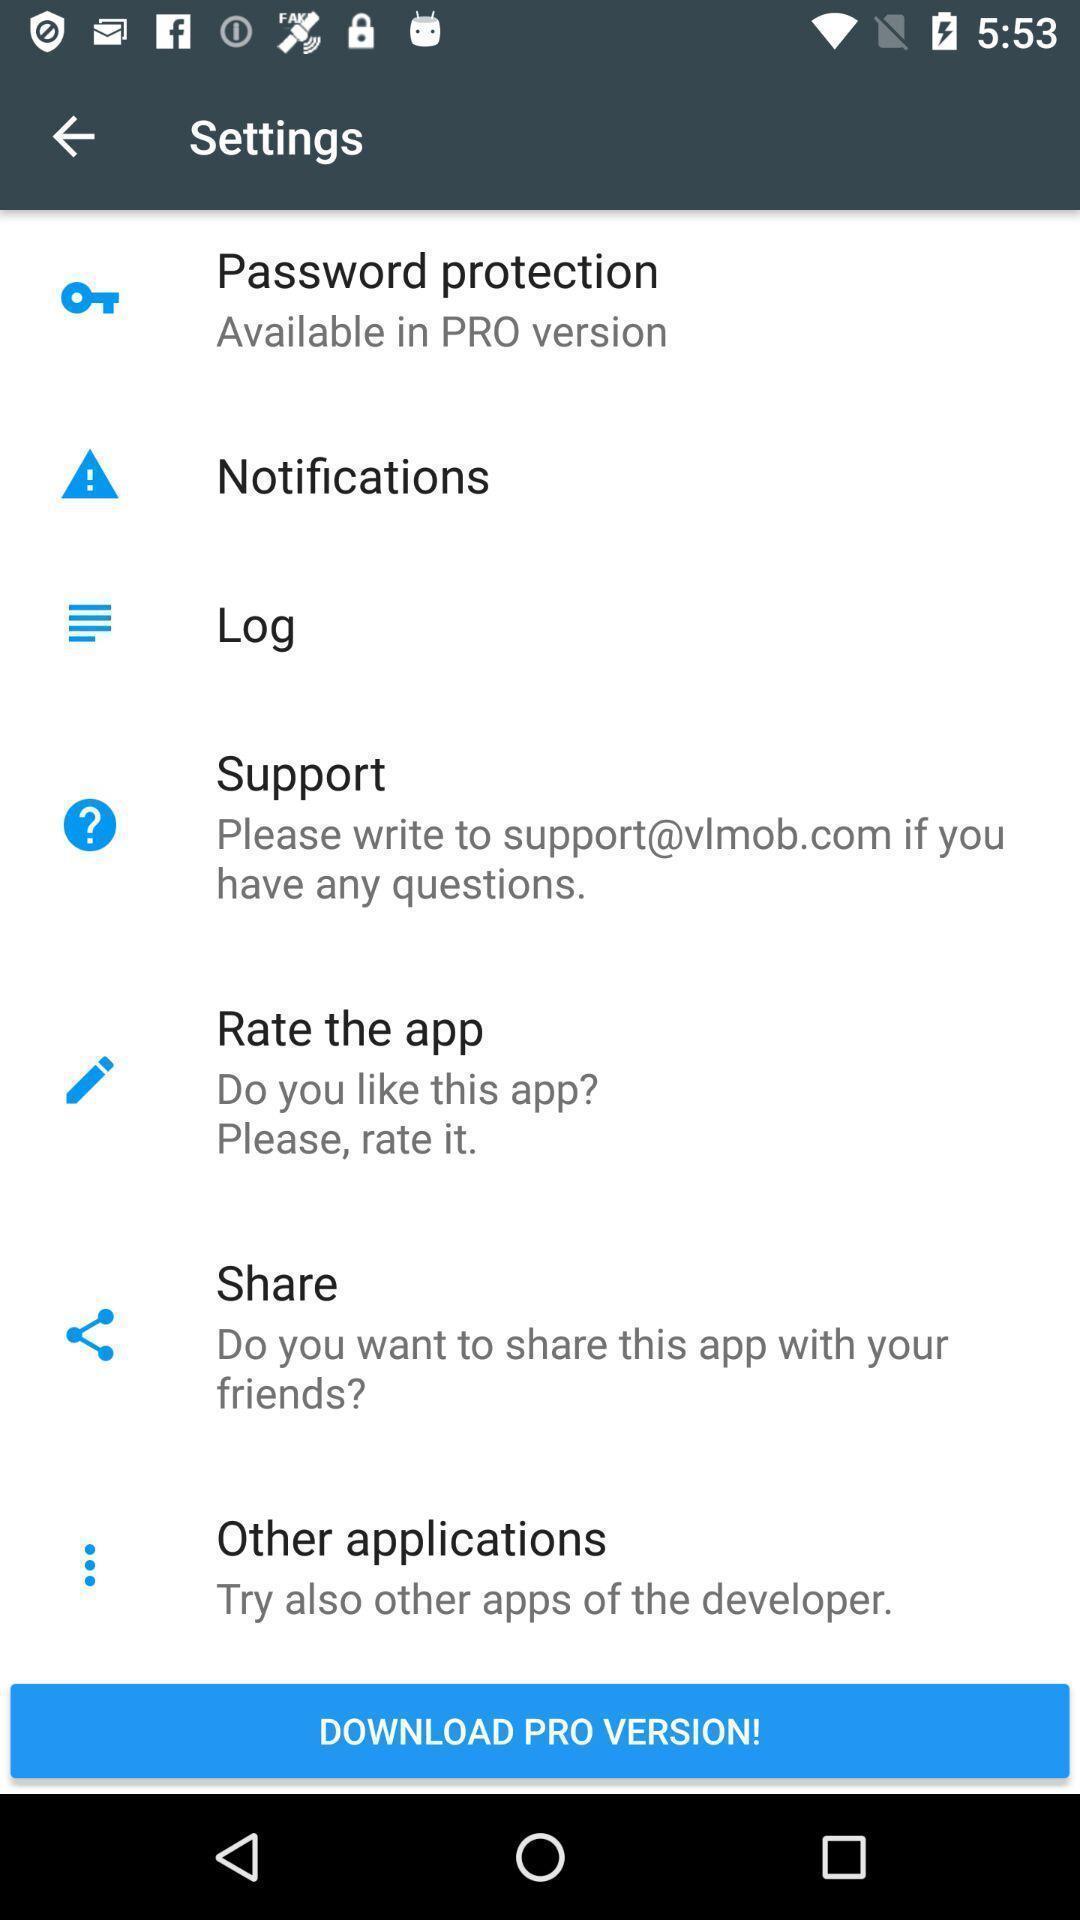Explain what's happening in this screen capture. Setting page displaying various options. 